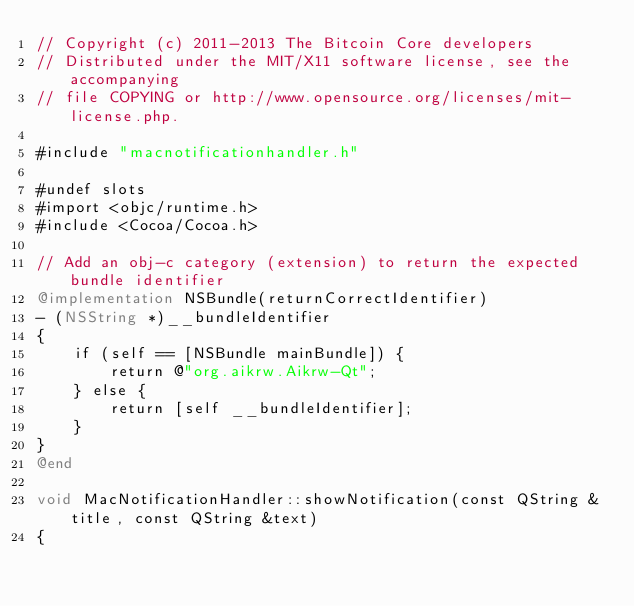<code> <loc_0><loc_0><loc_500><loc_500><_ObjectiveC_>// Copyright (c) 2011-2013 The Bitcoin Core developers
// Distributed under the MIT/X11 software license, see the accompanying
// file COPYING or http://www.opensource.org/licenses/mit-license.php.

#include "macnotificationhandler.h"

#undef slots
#import <objc/runtime.h>
#include <Cocoa/Cocoa.h>

// Add an obj-c category (extension) to return the expected bundle identifier
@implementation NSBundle(returnCorrectIdentifier)
- (NSString *)__bundleIdentifier
{
    if (self == [NSBundle mainBundle]) {
        return @"org.aikrw.Aikrw-Qt";
    } else {
        return [self __bundleIdentifier];
    }
}
@end

void MacNotificationHandler::showNotification(const QString &title, const QString &text)
{</code> 